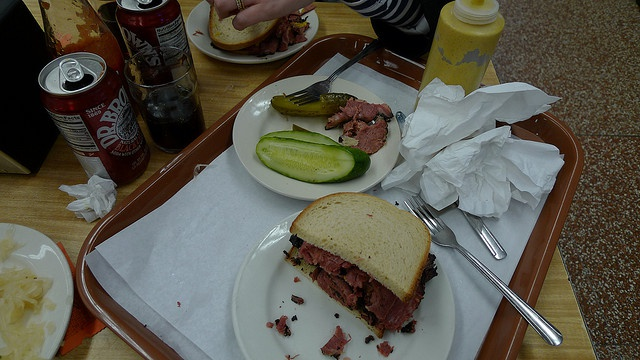Describe the objects in this image and their specific colors. I can see dining table in black and olive tones, sandwich in black, gray, and maroon tones, cup in black, darkgreen, and gray tones, bottle in black, olive, gray, and darkgray tones, and people in black and gray tones in this image. 